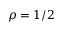Convert formula to latex. <formula><loc_0><loc_0><loc_500><loc_500>\rho = 1 / 2</formula> 